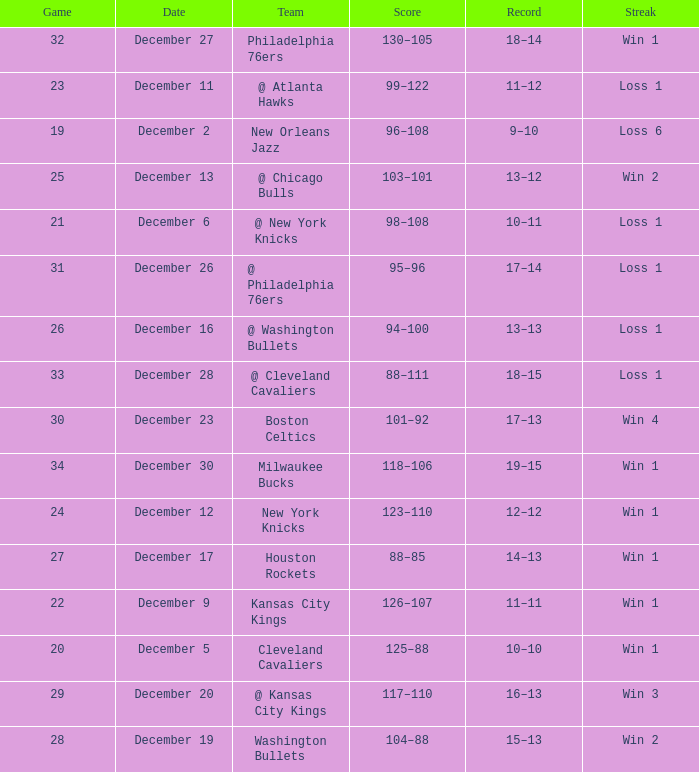What Game had a Score of 101–92? 30.0. 